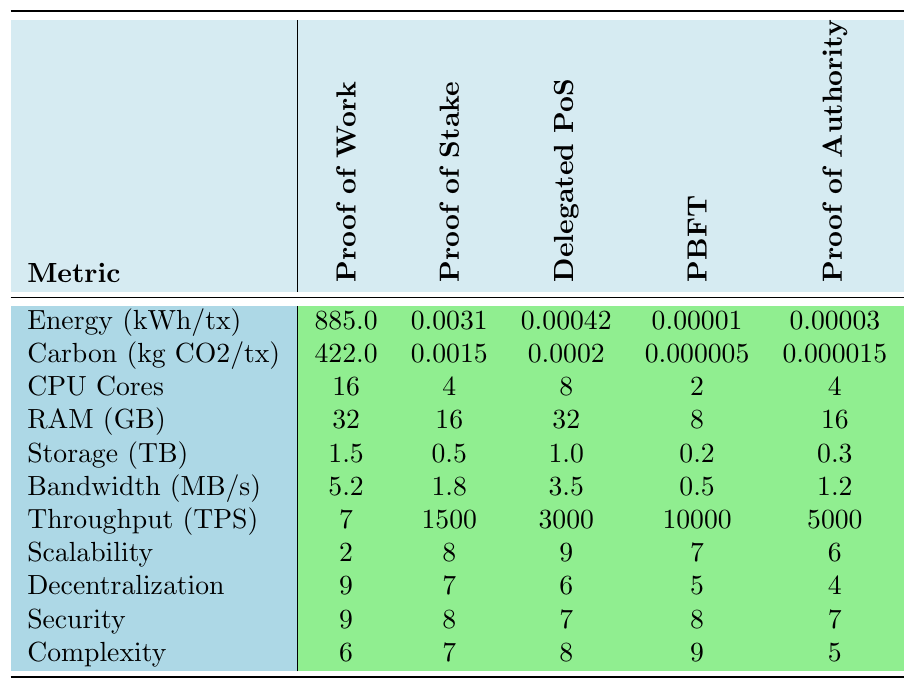What is the energy consumption per transaction for Proof of Work? The table shows that the energy consumption for Proof of Work is listed as 885.0 kWh per transaction.
Answer: 885.0 kWh What is the carbon footprint per transaction for Delegated Proof of Stake? According to the table, the carbon footprint for Delegated Proof of Stake is 0.0002 kg CO2 per transaction.
Answer: 0.0002 kg CO2 How much RAM is required for Practical Byzantine Fault Tolerance? The RAM requirement for Practical Byzantine Fault Tolerance is specified as 8 GB in the table.
Answer: 8 GB Which consensus mechanism requires the least energy consumption per transaction? By comparing the energy consumption values, Proof of Stake (0.0031 kWh) requires the least energy per transaction compared to the others.
Answer: Proof of Stake Calculate the difference in carbon footprint between Proof of Work and Proof of Authority. The carbon footprint for Proof of Work is 422.0 kg CO2, and for Proof of Authority, it is 0.000015 kg CO2. The difference is 422.0 - 0.000015 = 421.999985 kg CO2.
Answer: 421.999985 kg CO2 Which consensus mechanism has the highest transaction throughput? Examining the transaction throughput values, Practical Byzantine Fault Tolerance has the highest throughput at 10,000 transactions per second.
Answer: Practical Byzantine Fault Tolerance Is the hardware requirement for CPU cores higher in Proof of Work or Delegated Proof of Stake? The table shows that Proof of Work requires 16 CPU cores, whereas Delegated Proof of Stake requires 8 CPU cores. Thus, Proof of Work has a higher requirement.
Answer: Yes What is the average scalability score of Proof of Stake and Delegated Proof of Stake? The scalability score for Proof of Stake is 8 and for Delegated Proof of Stake is 9. The average is (8 + 9) / 2 = 8.5.
Answer: 8.5 If we consider energy consumption and carbon footprint, which mechanism has the worst combined environmental impact? The worst combined impact can be calculated by summing the energy consumption (kWh/tx) and carbon footprint (kg CO2/tx) for each mechanism. Proof of Work has the highest combined value of 885.0 + 422.0 = 1307.0, indicating it has the worst impact.
Answer: Proof of Work Which consensus mechanism has the lowest decentralization score? The table indicates that Proof of Authority has the lowest decentralization score of 4.
Answer: Proof of Authority 